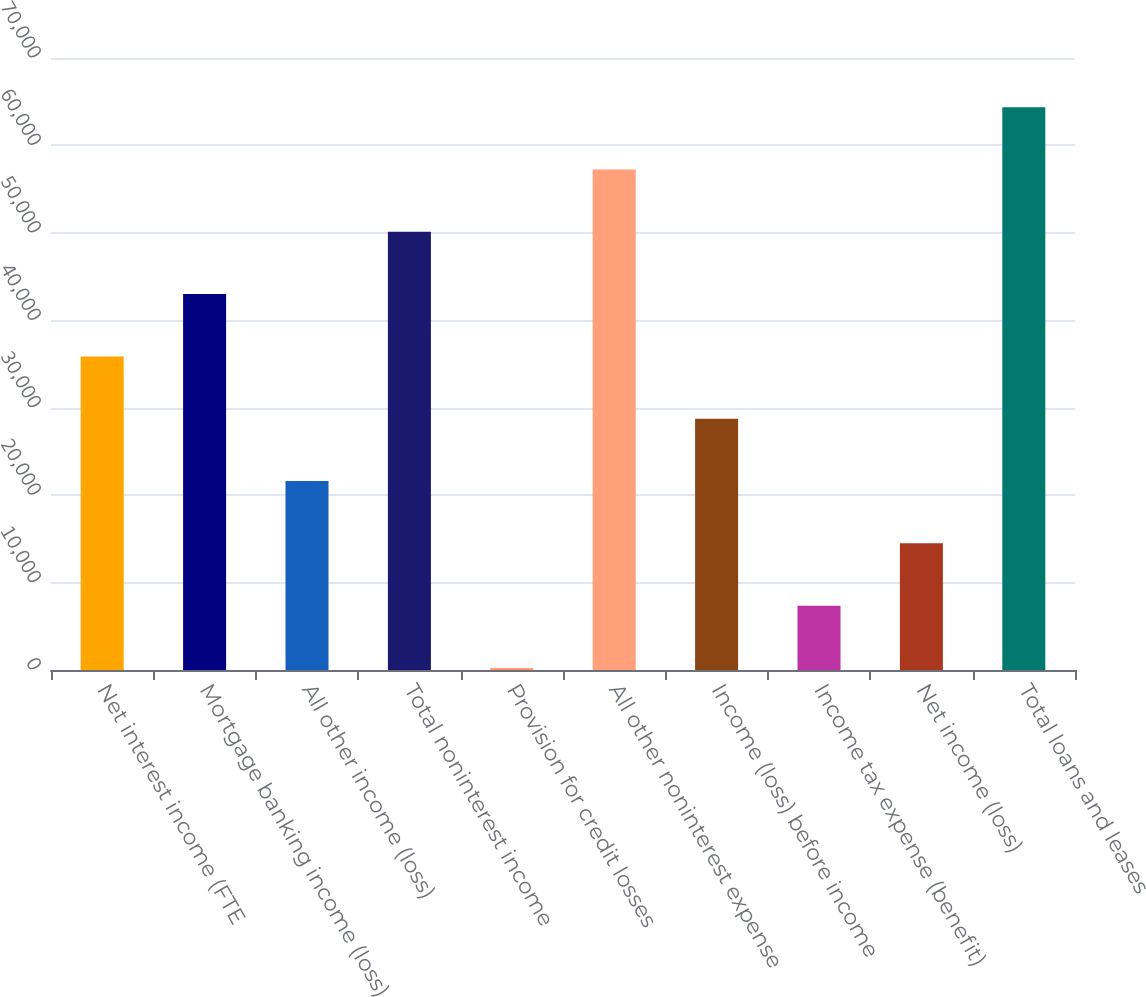Convert chart. <chart><loc_0><loc_0><loc_500><loc_500><bar_chart><fcel>Net interest income (FTE<fcel>Mortgage banking income (loss)<fcel>All other income (loss)<fcel>Total noninterest income<fcel>Provision for credit losses<fcel>All other noninterest expense<fcel>Income (loss) before income<fcel>Income tax expense (benefit)<fcel>Net income (loss)<fcel>Total loans and leases<nl><fcel>35870.5<fcel>42998<fcel>21615.5<fcel>50125.5<fcel>233<fcel>57253<fcel>28743<fcel>7360.5<fcel>14488<fcel>64380.5<nl></chart> 